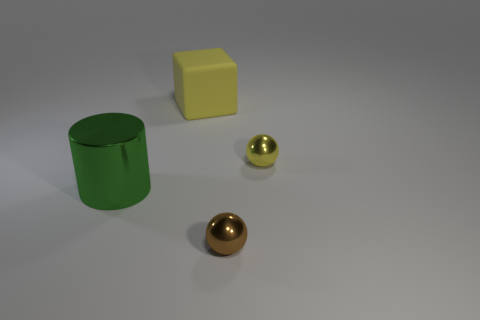There is another object that is the same color as the large rubber thing; what is its material?
Your response must be concise. Metal. Is there a tiny ball of the same color as the matte block?
Provide a succinct answer. Yes. There is a thing that is both behind the shiny cylinder and in front of the large rubber thing; what is its size?
Ensure brevity in your answer.  Small. How many cylinders are gray metallic objects or green objects?
Your response must be concise. 1. What color is the matte block that is the same size as the green shiny cylinder?
Your answer should be compact. Yellow. Are there any other things that are the same shape as the tiny yellow metallic object?
Your answer should be very brief. Yes. What color is the other object that is the same shape as the small brown shiny thing?
Keep it short and to the point. Yellow. What number of things are either big red shiny spheres or green metallic objects to the left of the tiny brown ball?
Give a very brief answer. 1. Are there fewer large blocks that are on the left side of the big yellow cube than tiny yellow spheres?
Make the answer very short. Yes. How big is the rubber thing that is behind the tiny ball that is in front of the metal object that is to the left of the yellow block?
Provide a short and direct response. Large. 